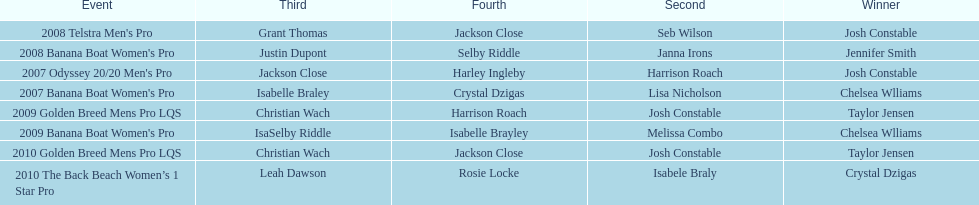In what two races did chelsea williams earn the same rank? 2007 Banana Boat Women's Pro, 2009 Banana Boat Women's Pro. 